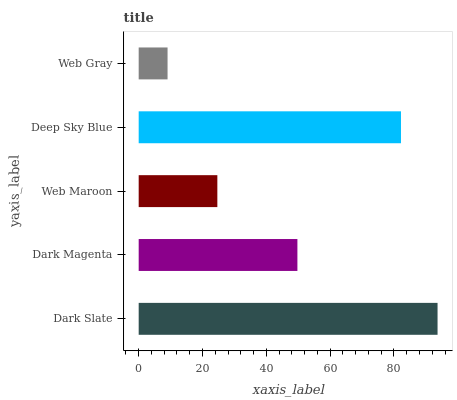Is Web Gray the minimum?
Answer yes or no. Yes. Is Dark Slate the maximum?
Answer yes or no. Yes. Is Dark Magenta the minimum?
Answer yes or no. No. Is Dark Magenta the maximum?
Answer yes or no. No. Is Dark Slate greater than Dark Magenta?
Answer yes or no. Yes. Is Dark Magenta less than Dark Slate?
Answer yes or no. Yes. Is Dark Magenta greater than Dark Slate?
Answer yes or no. No. Is Dark Slate less than Dark Magenta?
Answer yes or no. No. Is Dark Magenta the high median?
Answer yes or no. Yes. Is Dark Magenta the low median?
Answer yes or no. Yes. Is Dark Slate the high median?
Answer yes or no. No. Is Web Gray the low median?
Answer yes or no. No. 